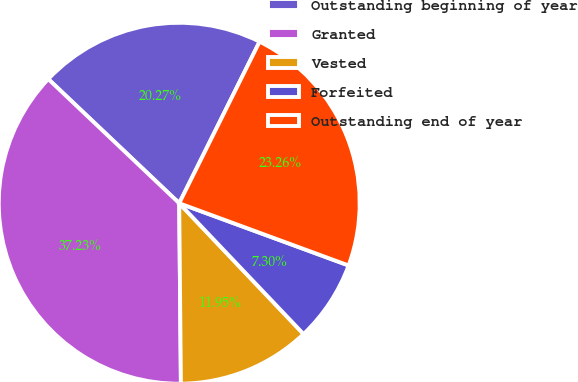Convert chart to OTSL. <chart><loc_0><loc_0><loc_500><loc_500><pie_chart><fcel>Outstanding beginning of year<fcel>Granted<fcel>Vested<fcel>Forfeited<fcel>Outstanding end of year<nl><fcel>20.27%<fcel>37.23%<fcel>11.95%<fcel>7.3%<fcel>23.26%<nl></chart> 